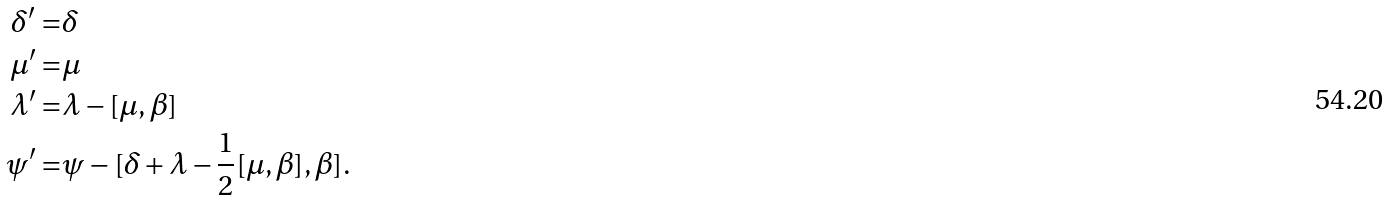Convert formula to latex. <formula><loc_0><loc_0><loc_500><loc_500>\delta ^ { \prime } = & \delta \\ \mu ^ { \prime } = & \mu \\ \lambda ^ { \prime } = & \lambda - [ \mu , \beta ] \\ \psi ^ { \prime } = & \psi - [ \delta + \lambda - \frac { 1 } { 2 } [ \mu , \beta ] , \beta ] .</formula> 